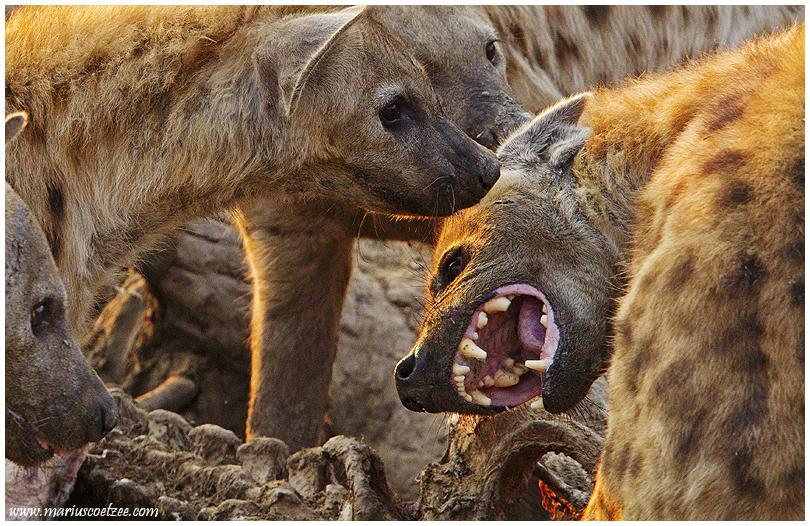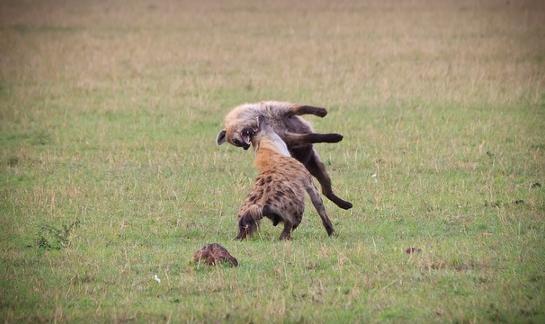The first image is the image on the left, the second image is the image on the right. Analyze the images presented: Is the assertion "There are at least three hyenas eating  a dead animal." valid? Answer yes or no. Yes. 